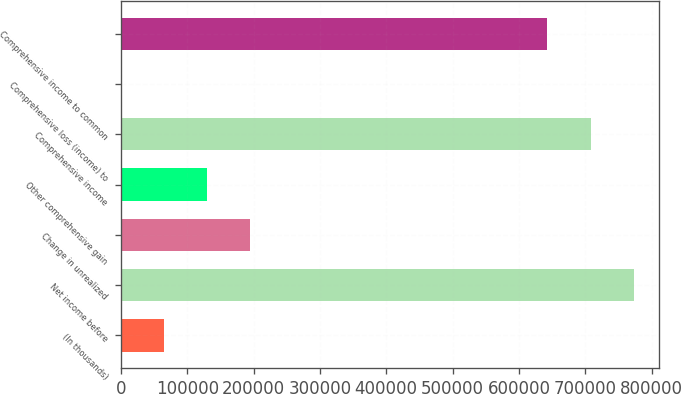Convert chart to OTSL. <chart><loc_0><loc_0><loc_500><loc_500><bar_chart><fcel>(In thousands)<fcel>Net income before<fcel>Change in unrealized<fcel>Other comprehensive gain<fcel>Comprehensive income<fcel>Comprehensive loss (income) to<fcel>Comprehensive income to common<nl><fcel>65637.1<fcel>772813<fcel>195407<fcel>130522<fcel>707928<fcel>752<fcel>643043<nl></chart> 